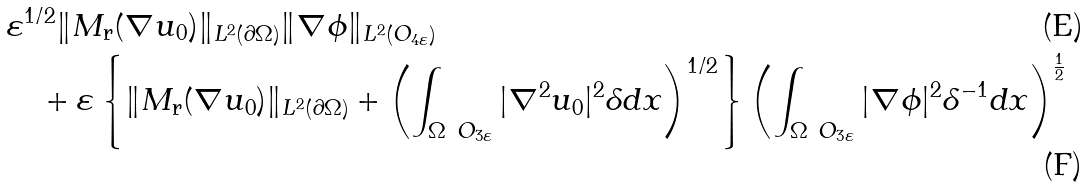Convert formula to latex. <formula><loc_0><loc_0><loc_500><loc_500>& \varepsilon ^ { 1 / 2 } \| M _ { \text {r} } ( \nabla u _ { 0 } ) \| _ { L ^ { 2 } ( \partial \Omega ) } \| \nabla \phi \| _ { L ^ { 2 } ( O _ { 4 \varepsilon } ) } \\ & \quad + \varepsilon \left \{ \| M _ { \text {r} } ( \nabla u _ { 0 } ) \| _ { L ^ { 2 } ( \partial \Omega ) } + \left ( \int _ { \Omega \ O _ { 3 \varepsilon } } | \nabla ^ { 2 } u _ { 0 } | ^ { 2 } \delta d x \right ) ^ { 1 / 2 } \right \} \left ( \int _ { \Omega \ O _ { 3 \varepsilon } } | \nabla \phi | ^ { 2 } \delta ^ { - 1 } d x \right ) ^ { \frac { 1 } { 2 } }</formula> 